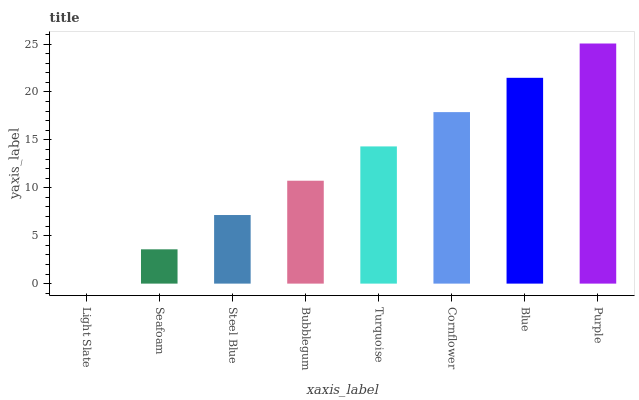Is Light Slate the minimum?
Answer yes or no. Yes. Is Purple the maximum?
Answer yes or no. Yes. Is Seafoam the minimum?
Answer yes or no. No. Is Seafoam the maximum?
Answer yes or no. No. Is Seafoam greater than Light Slate?
Answer yes or no. Yes. Is Light Slate less than Seafoam?
Answer yes or no. Yes. Is Light Slate greater than Seafoam?
Answer yes or no. No. Is Seafoam less than Light Slate?
Answer yes or no. No. Is Turquoise the high median?
Answer yes or no. Yes. Is Bubblegum the low median?
Answer yes or no. Yes. Is Light Slate the high median?
Answer yes or no. No. Is Seafoam the low median?
Answer yes or no. No. 